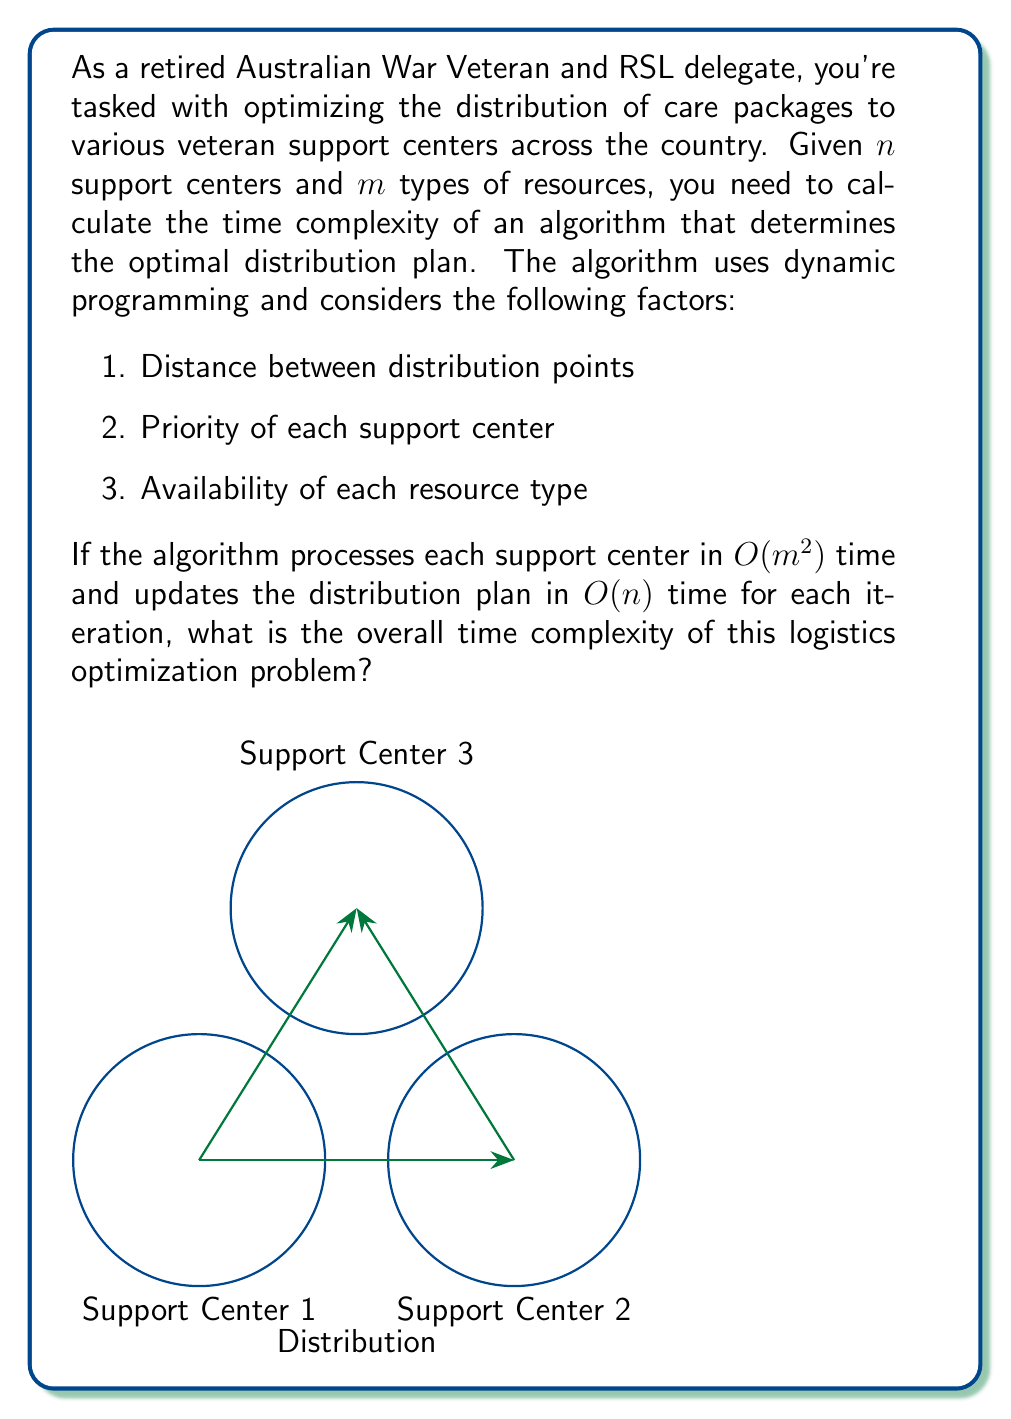Solve this math problem. Let's break down the problem and analyze it step by step:

1. We have $n$ support centers and $m$ types of resources.

2. For each support center, the algorithm performs operations that take $O(m^2)$ time. This likely involves calculations related to resource allocation and prioritization.

3. After processing each center, the algorithm updates the distribution plan, which takes $O(n)$ time. This update probably involves adjusting allocations based on the latest center's needs and the overall distribution strategy.

4. These two steps (processing a center and updating the plan) are performed for each of the $n$ centers.

5. Therefore, for each center, we have:
   - Center processing: $O(m^2)$
   - Plan update: $O(n)$

6. The total time for one center is thus $O(m^2 + n)$.

7. Since this is done for all $n$ centers, we multiply by $n$:
   
   $$O(n(m^2 + n)) = O(nm^2 + n^2)$$

8. In big O notation, we keep the term that grows the fastest. Here, it depends on the relative sizes of $n$ and $m$:
   - If $n > m$, then $n^2$ grows faster than $nm^2$
   - If $m > \sqrt{n}$, then $nm^2$ grows faster than $n^2$

9. To account for both cases, we express the time complexity as:

   $$O(\max(nm^2, n^2))$$

This represents the worst-case time complexity of the algorithm, considering both the number of support centers and the types of resources.
Answer: $O(\max(nm^2, n^2))$ 